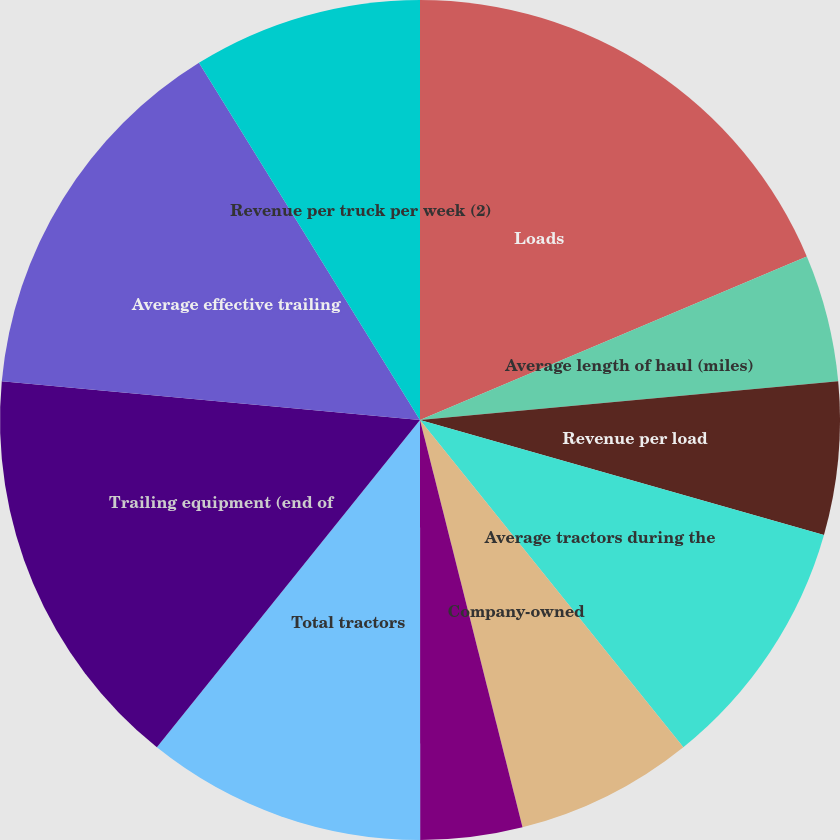Convert chart. <chart><loc_0><loc_0><loc_500><loc_500><pie_chart><fcel>Loads<fcel>Average length of haul (miles)<fcel>Revenue per load<fcel>Average tractors during the<fcel>Company-owned<fcel>Independent contractor<fcel>Total tractors<fcel>Trailing equipment (end of<fcel>Average effective trailing<fcel>Revenue per truck per week (2)<nl><fcel>18.63%<fcel>4.9%<fcel>5.88%<fcel>9.8%<fcel>6.86%<fcel>3.92%<fcel>10.78%<fcel>15.69%<fcel>14.71%<fcel>8.82%<nl></chart> 